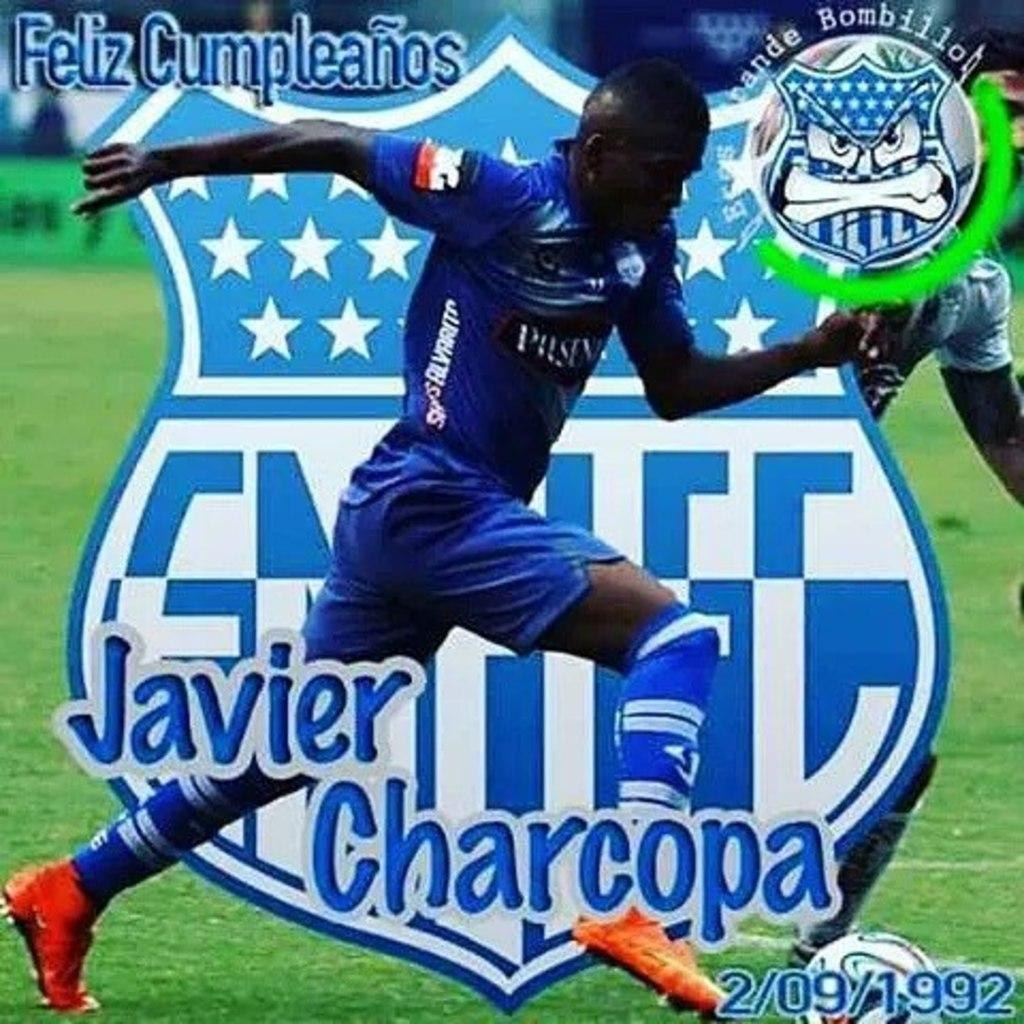<image>
Write a terse but informative summary of the picture. The player in the blue uniform is Javier Charcopa 